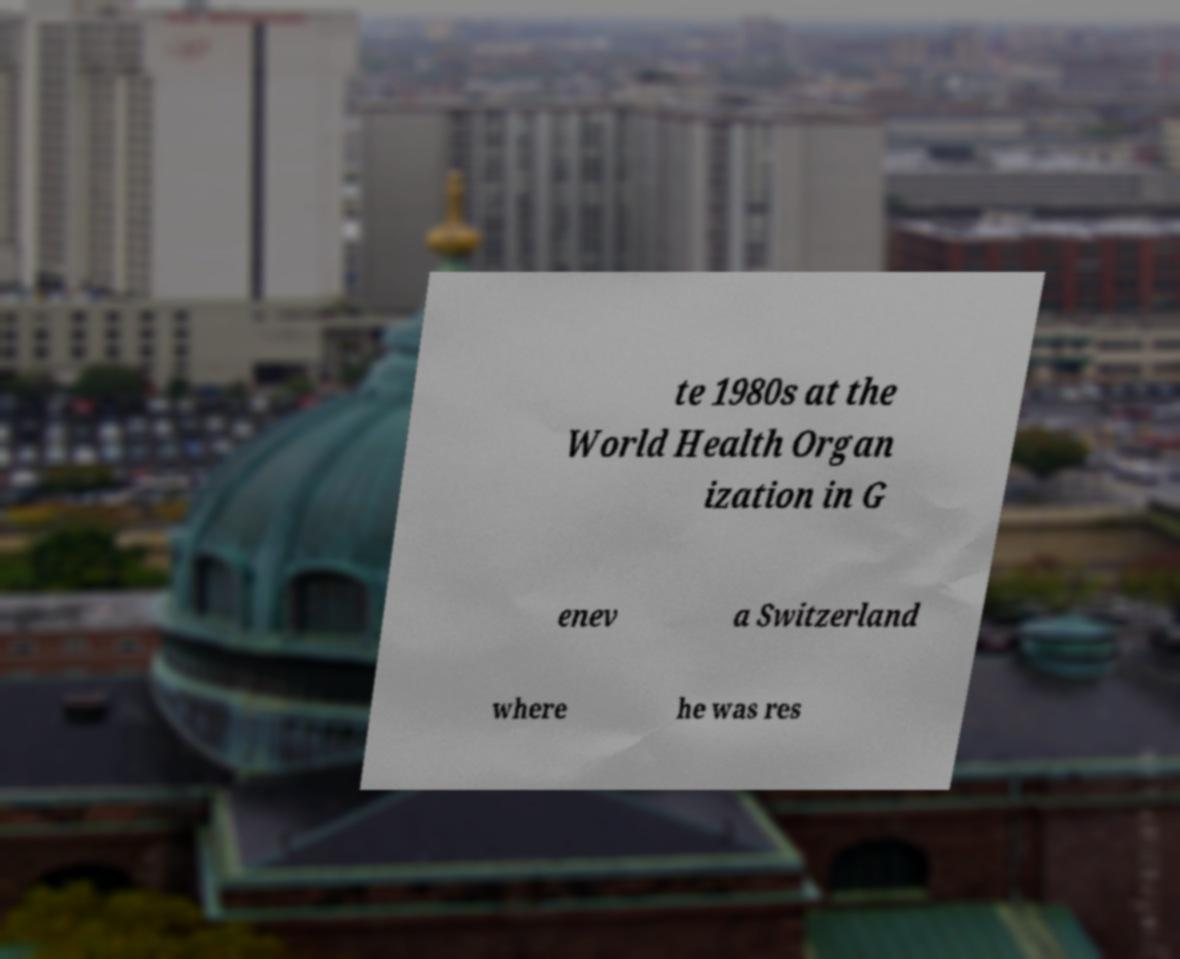There's text embedded in this image that I need extracted. Can you transcribe it verbatim? te 1980s at the World Health Organ ization in G enev a Switzerland where he was res 